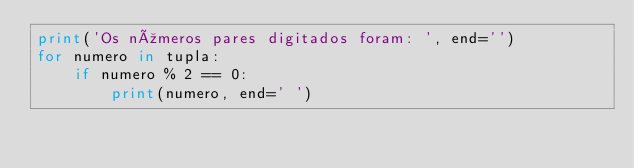<code> <loc_0><loc_0><loc_500><loc_500><_Python_>print('Os números pares digitados foram: ', end='')
for numero in tupla:
    if numero % 2 == 0:
        print(numero, end=' ')
</code> 